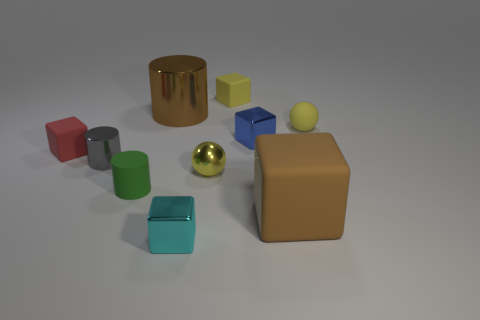Subtract all small cylinders. How many cylinders are left? 1 Subtract all red blocks. How many blocks are left? 4 Subtract 2 spheres. How many spheres are left? 0 Subtract all cylinders. How many objects are left? 7 Subtract all gray spheres. How many brown cylinders are left? 1 Subtract all large metal cylinders. Subtract all gray cylinders. How many objects are left? 8 Add 5 yellow rubber balls. How many yellow rubber balls are left? 6 Add 7 yellow matte objects. How many yellow matte objects exist? 9 Subtract 0 gray cubes. How many objects are left? 10 Subtract all red balls. Subtract all purple cylinders. How many balls are left? 2 